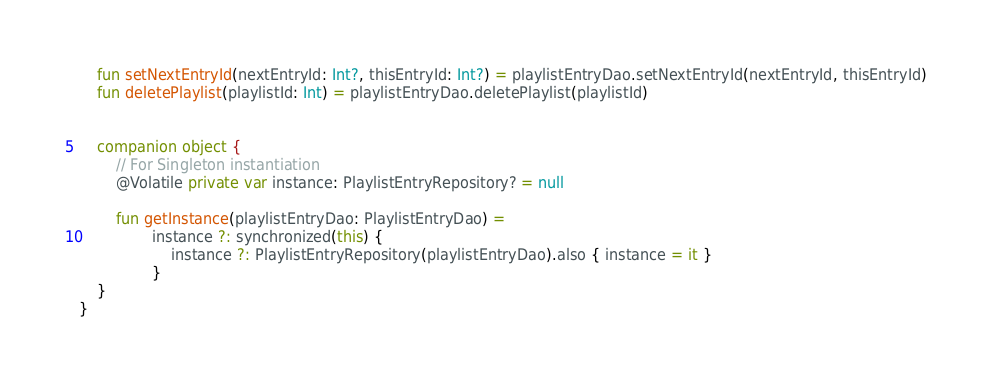<code> <loc_0><loc_0><loc_500><loc_500><_Kotlin_>    fun setNextEntryId(nextEntryId: Int?, thisEntryId: Int?) = playlistEntryDao.setNextEntryId(nextEntryId, thisEntryId)
    fun deletePlaylist(playlistId: Int) = playlistEntryDao.deletePlaylist(playlistId)


    companion object {
        // For Singleton instantiation
        @Volatile private var instance: PlaylistEntryRepository? = null

        fun getInstance(playlistEntryDao: PlaylistEntryDao) =
                instance ?: synchronized(this) {
                    instance ?: PlaylistEntryRepository(playlistEntryDao).also { instance = it }
                }
    }
}</code> 